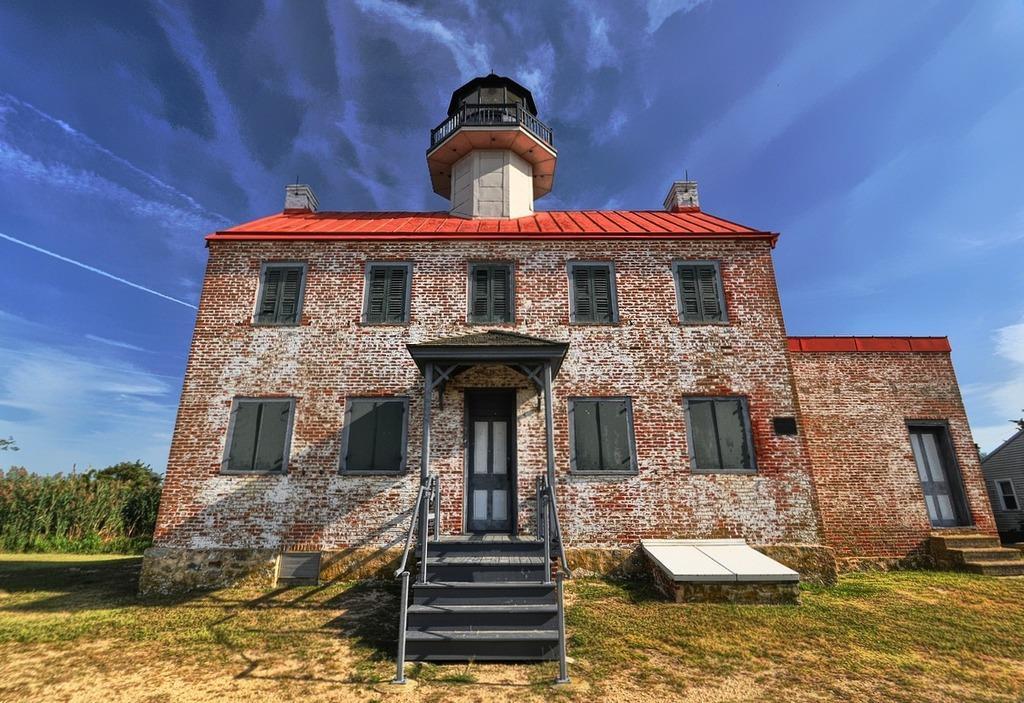How would you summarize this image in a sentence or two? In this image I can see a building. In front of this building there are some stairs and ground. On the left side, I can see some trees. On the top of the image I can see the sky. 